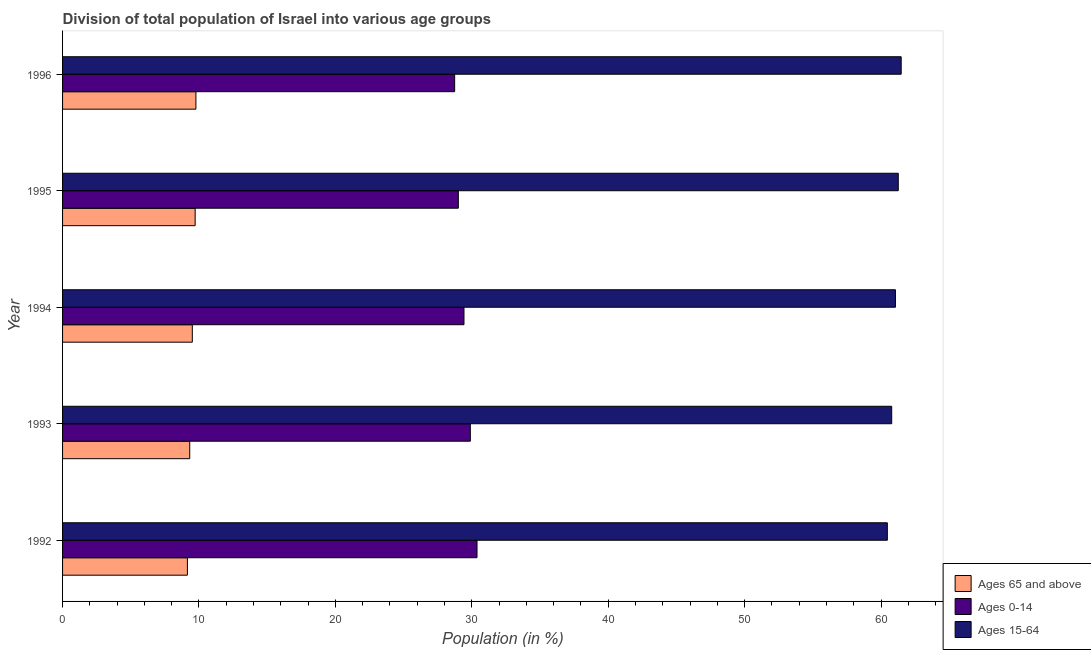How many different coloured bars are there?
Offer a very short reply. 3. Are the number of bars per tick equal to the number of legend labels?
Offer a very short reply. Yes. What is the label of the 5th group of bars from the top?
Offer a very short reply. 1992. What is the percentage of population within the age-group 15-64 in 1994?
Make the answer very short. 61.06. Across all years, what is the maximum percentage of population within the age-group 15-64?
Give a very brief answer. 61.48. Across all years, what is the minimum percentage of population within the age-group 15-64?
Your answer should be compact. 60.47. In which year was the percentage of population within the age-group 15-64 maximum?
Your response must be concise. 1996. What is the total percentage of population within the age-group 15-64 in the graph?
Provide a succinct answer. 305.05. What is the difference between the percentage of population within the age-group 0-14 in 1994 and that in 1995?
Your answer should be very brief. 0.41. What is the difference between the percentage of population within the age-group 0-14 in 1996 and the percentage of population within the age-group of 65 and above in 1993?
Your answer should be compact. 19.42. What is the average percentage of population within the age-group 15-64 per year?
Provide a succinct answer. 61.01. In the year 1994, what is the difference between the percentage of population within the age-group 15-64 and percentage of population within the age-group of 65 and above?
Offer a very short reply. 51.55. In how many years, is the percentage of population within the age-group 0-14 greater than 36 %?
Offer a terse response. 0. What is the difference between the highest and the second highest percentage of population within the age-group 15-64?
Make the answer very short. 0.21. What is the difference between the highest and the lowest percentage of population within the age-group 0-14?
Keep it short and to the point. 1.64. Is the sum of the percentage of population within the age-group of 65 and above in 1993 and 1996 greater than the maximum percentage of population within the age-group 15-64 across all years?
Offer a very short reply. No. What does the 1st bar from the top in 1993 represents?
Your answer should be very brief. Ages 15-64. What does the 3rd bar from the bottom in 1992 represents?
Keep it short and to the point. Ages 15-64. Is it the case that in every year, the sum of the percentage of population within the age-group of 65 and above and percentage of population within the age-group 0-14 is greater than the percentage of population within the age-group 15-64?
Your response must be concise. No. Are all the bars in the graph horizontal?
Ensure brevity in your answer.  Yes. What is the difference between two consecutive major ticks on the X-axis?
Make the answer very short. 10. Where does the legend appear in the graph?
Your answer should be very brief. Bottom right. How many legend labels are there?
Offer a terse response. 3. How are the legend labels stacked?
Keep it short and to the point. Vertical. What is the title of the graph?
Provide a short and direct response. Division of total population of Israel into various age groups
. Does "Neonatal" appear as one of the legend labels in the graph?
Your response must be concise. No. What is the label or title of the X-axis?
Provide a succinct answer. Population (in %). What is the label or title of the Y-axis?
Provide a short and direct response. Year. What is the Population (in %) of Ages 65 and above in 1992?
Keep it short and to the point. 9.15. What is the Population (in %) in Ages 0-14 in 1992?
Your response must be concise. 30.38. What is the Population (in %) of Ages 15-64 in 1992?
Your answer should be very brief. 60.47. What is the Population (in %) in Ages 65 and above in 1993?
Your answer should be very brief. 9.32. What is the Population (in %) of Ages 0-14 in 1993?
Offer a terse response. 29.89. What is the Population (in %) of Ages 15-64 in 1993?
Your answer should be very brief. 60.78. What is the Population (in %) in Ages 65 and above in 1994?
Your answer should be very brief. 9.51. What is the Population (in %) in Ages 0-14 in 1994?
Your answer should be very brief. 29.43. What is the Population (in %) in Ages 15-64 in 1994?
Your answer should be very brief. 61.06. What is the Population (in %) in Ages 65 and above in 1995?
Offer a terse response. 9.72. What is the Population (in %) in Ages 0-14 in 1995?
Make the answer very short. 29.01. What is the Population (in %) of Ages 15-64 in 1995?
Offer a terse response. 61.27. What is the Population (in %) in Ages 65 and above in 1996?
Offer a very short reply. 9.78. What is the Population (in %) in Ages 0-14 in 1996?
Give a very brief answer. 28.74. What is the Population (in %) of Ages 15-64 in 1996?
Your response must be concise. 61.48. Across all years, what is the maximum Population (in %) in Ages 65 and above?
Ensure brevity in your answer.  9.78. Across all years, what is the maximum Population (in %) in Ages 0-14?
Give a very brief answer. 30.38. Across all years, what is the maximum Population (in %) of Ages 15-64?
Your response must be concise. 61.48. Across all years, what is the minimum Population (in %) in Ages 65 and above?
Offer a terse response. 9.15. Across all years, what is the minimum Population (in %) in Ages 0-14?
Your response must be concise. 28.74. Across all years, what is the minimum Population (in %) of Ages 15-64?
Ensure brevity in your answer.  60.47. What is the total Population (in %) of Ages 65 and above in the graph?
Offer a very short reply. 47.48. What is the total Population (in %) in Ages 0-14 in the graph?
Your answer should be compact. 147.46. What is the total Population (in %) of Ages 15-64 in the graph?
Your answer should be compact. 305.05. What is the difference between the Population (in %) of Ages 65 and above in 1992 and that in 1993?
Your response must be concise. -0.17. What is the difference between the Population (in %) in Ages 0-14 in 1992 and that in 1993?
Ensure brevity in your answer.  0.49. What is the difference between the Population (in %) of Ages 15-64 in 1992 and that in 1993?
Make the answer very short. -0.32. What is the difference between the Population (in %) of Ages 65 and above in 1992 and that in 1994?
Offer a terse response. -0.36. What is the difference between the Population (in %) in Ages 0-14 in 1992 and that in 1994?
Provide a short and direct response. 0.95. What is the difference between the Population (in %) in Ages 15-64 in 1992 and that in 1994?
Offer a terse response. -0.59. What is the difference between the Population (in %) in Ages 65 and above in 1992 and that in 1995?
Your answer should be compact. -0.57. What is the difference between the Population (in %) in Ages 0-14 in 1992 and that in 1995?
Offer a terse response. 1.37. What is the difference between the Population (in %) of Ages 15-64 in 1992 and that in 1995?
Your response must be concise. -0.8. What is the difference between the Population (in %) in Ages 65 and above in 1992 and that in 1996?
Offer a very short reply. -0.62. What is the difference between the Population (in %) of Ages 0-14 in 1992 and that in 1996?
Ensure brevity in your answer.  1.64. What is the difference between the Population (in %) of Ages 15-64 in 1992 and that in 1996?
Make the answer very short. -1.01. What is the difference between the Population (in %) of Ages 65 and above in 1993 and that in 1994?
Provide a short and direct response. -0.19. What is the difference between the Population (in %) of Ages 0-14 in 1993 and that in 1994?
Offer a terse response. 0.46. What is the difference between the Population (in %) of Ages 15-64 in 1993 and that in 1994?
Your answer should be very brief. -0.27. What is the difference between the Population (in %) in Ages 65 and above in 1993 and that in 1995?
Provide a short and direct response. -0.4. What is the difference between the Population (in %) in Ages 0-14 in 1993 and that in 1995?
Give a very brief answer. 0.88. What is the difference between the Population (in %) in Ages 15-64 in 1993 and that in 1995?
Your answer should be very brief. -0.48. What is the difference between the Population (in %) in Ages 65 and above in 1993 and that in 1996?
Provide a succinct answer. -0.45. What is the difference between the Population (in %) of Ages 0-14 in 1993 and that in 1996?
Ensure brevity in your answer.  1.15. What is the difference between the Population (in %) of Ages 15-64 in 1993 and that in 1996?
Your response must be concise. -0.7. What is the difference between the Population (in %) of Ages 65 and above in 1994 and that in 1995?
Make the answer very short. -0.21. What is the difference between the Population (in %) in Ages 0-14 in 1994 and that in 1995?
Your answer should be compact. 0.41. What is the difference between the Population (in %) in Ages 15-64 in 1994 and that in 1995?
Provide a short and direct response. -0.21. What is the difference between the Population (in %) of Ages 65 and above in 1994 and that in 1996?
Your response must be concise. -0.26. What is the difference between the Population (in %) of Ages 0-14 in 1994 and that in 1996?
Offer a very short reply. 0.68. What is the difference between the Population (in %) of Ages 15-64 in 1994 and that in 1996?
Offer a terse response. -0.42. What is the difference between the Population (in %) in Ages 65 and above in 1995 and that in 1996?
Provide a short and direct response. -0.06. What is the difference between the Population (in %) of Ages 0-14 in 1995 and that in 1996?
Your answer should be compact. 0.27. What is the difference between the Population (in %) of Ages 15-64 in 1995 and that in 1996?
Offer a terse response. -0.21. What is the difference between the Population (in %) in Ages 65 and above in 1992 and the Population (in %) in Ages 0-14 in 1993?
Your answer should be compact. -20.74. What is the difference between the Population (in %) in Ages 65 and above in 1992 and the Population (in %) in Ages 15-64 in 1993?
Ensure brevity in your answer.  -51.63. What is the difference between the Population (in %) in Ages 0-14 in 1992 and the Population (in %) in Ages 15-64 in 1993?
Your answer should be compact. -30.4. What is the difference between the Population (in %) of Ages 65 and above in 1992 and the Population (in %) of Ages 0-14 in 1994?
Provide a short and direct response. -20.28. What is the difference between the Population (in %) of Ages 65 and above in 1992 and the Population (in %) of Ages 15-64 in 1994?
Your response must be concise. -51.91. What is the difference between the Population (in %) in Ages 0-14 in 1992 and the Population (in %) in Ages 15-64 in 1994?
Give a very brief answer. -30.68. What is the difference between the Population (in %) of Ages 65 and above in 1992 and the Population (in %) of Ages 0-14 in 1995?
Your answer should be compact. -19.86. What is the difference between the Population (in %) in Ages 65 and above in 1992 and the Population (in %) in Ages 15-64 in 1995?
Offer a terse response. -52.11. What is the difference between the Population (in %) in Ages 0-14 in 1992 and the Population (in %) in Ages 15-64 in 1995?
Ensure brevity in your answer.  -30.88. What is the difference between the Population (in %) in Ages 65 and above in 1992 and the Population (in %) in Ages 0-14 in 1996?
Ensure brevity in your answer.  -19.59. What is the difference between the Population (in %) of Ages 65 and above in 1992 and the Population (in %) of Ages 15-64 in 1996?
Provide a succinct answer. -52.33. What is the difference between the Population (in %) in Ages 0-14 in 1992 and the Population (in %) in Ages 15-64 in 1996?
Your answer should be compact. -31.1. What is the difference between the Population (in %) of Ages 65 and above in 1993 and the Population (in %) of Ages 0-14 in 1994?
Give a very brief answer. -20.11. What is the difference between the Population (in %) of Ages 65 and above in 1993 and the Population (in %) of Ages 15-64 in 1994?
Provide a succinct answer. -51.74. What is the difference between the Population (in %) of Ages 0-14 in 1993 and the Population (in %) of Ages 15-64 in 1994?
Your answer should be very brief. -31.17. What is the difference between the Population (in %) in Ages 65 and above in 1993 and the Population (in %) in Ages 0-14 in 1995?
Provide a succinct answer. -19.69. What is the difference between the Population (in %) of Ages 65 and above in 1993 and the Population (in %) of Ages 15-64 in 1995?
Give a very brief answer. -51.94. What is the difference between the Population (in %) of Ages 0-14 in 1993 and the Population (in %) of Ages 15-64 in 1995?
Ensure brevity in your answer.  -31.37. What is the difference between the Population (in %) in Ages 65 and above in 1993 and the Population (in %) in Ages 0-14 in 1996?
Provide a short and direct response. -19.42. What is the difference between the Population (in %) of Ages 65 and above in 1993 and the Population (in %) of Ages 15-64 in 1996?
Offer a terse response. -52.16. What is the difference between the Population (in %) in Ages 0-14 in 1993 and the Population (in %) in Ages 15-64 in 1996?
Your answer should be compact. -31.59. What is the difference between the Population (in %) in Ages 65 and above in 1994 and the Population (in %) in Ages 0-14 in 1995?
Make the answer very short. -19.5. What is the difference between the Population (in %) of Ages 65 and above in 1994 and the Population (in %) of Ages 15-64 in 1995?
Your answer should be very brief. -51.75. What is the difference between the Population (in %) of Ages 0-14 in 1994 and the Population (in %) of Ages 15-64 in 1995?
Provide a short and direct response. -31.84. What is the difference between the Population (in %) of Ages 65 and above in 1994 and the Population (in %) of Ages 0-14 in 1996?
Offer a very short reply. -19.23. What is the difference between the Population (in %) in Ages 65 and above in 1994 and the Population (in %) in Ages 15-64 in 1996?
Offer a terse response. -51.97. What is the difference between the Population (in %) in Ages 0-14 in 1994 and the Population (in %) in Ages 15-64 in 1996?
Offer a terse response. -32.05. What is the difference between the Population (in %) in Ages 65 and above in 1995 and the Population (in %) in Ages 0-14 in 1996?
Make the answer very short. -19.02. What is the difference between the Population (in %) in Ages 65 and above in 1995 and the Population (in %) in Ages 15-64 in 1996?
Offer a very short reply. -51.76. What is the difference between the Population (in %) of Ages 0-14 in 1995 and the Population (in %) of Ages 15-64 in 1996?
Your answer should be very brief. -32.47. What is the average Population (in %) of Ages 65 and above per year?
Your response must be concise. 9.5. What is the average Population (in %) of Ages 0-14 per year?
Offer a terse response. 29.49. What is the average Population (in %) of Ages 15-64 per year?
Your answer should be compact. 61.01. In the year 1992, what is the difference between the Population (in %) of Ages 65 and above and Population (in %) of Ages 0-14?
Provide a succinct answer. -21.23. In the year 1992, what is the difference between the Population (in %) in Ages 65 and above and Population (in %) in Ages 15-64?
Make the answer very short. -51.31. In the year 1992, what is the difference between the Population (in %) in Ages 0-14 and Population (in %) in Ages 15-64?
Your answer should be compact. -30.08. In the year 1993, what is the difference between the Population (in %) in Ages 65 and above and Population (in %) in Ages 0-14?
Your answer should be very brief. -20.57. In the year 1993, what is the difference between the Population (in %) in Ages 65 and above and Population (in %) in Ages 15-64?
Keep it short and to the point. -51.46. In the year 1993, what is the difference between the Population (in %) of Ages 0-14 and Population (in %) of Ages 15-64?
Provide a short and direct response. -30.89. In the year 1994, what is the difference between the Population (in %) of Ages 65 and above and Population (in %) of Ages 0-14?
Make the answer very short. -19.92. In the year 1994, what is the difference between the Population (in %) of Ages 65 and above and Population (in %) of Ages 15-64?
Your answer should be very brief. -51.55. In the year 1994, what is the difference between the Population (in %) of Ages 0-14 and Population (in %) of Ages 15-64?
Give a very brief answer. -31.63. In the year 1995, what is the difference between the Population (in %) in Ages 65 and above and Population (in %) in Ages 0-14?
Provide a succinct answer. -19.29. In the year 1995, what is the difference between the Population (in %) in Ages 65 and above and Population (in %) in Ages 15-64?
Keep it short and to the point. -51.55. In the year 1995, what is the difference between the Population (in %) of Ages 0-14 and Population (in %) of Ages 15-64?
Offer a very short reply. -32.25. In the year 1996, what is the difference between the Population (in %) of Ages 65 and above and Population (in %) of Ages 0-14?
Provide a short and direct response. -18.97. In the year 1996, what is the difference between the Population (in %) of Ages 65 and above and Population (in %) of Ages 15-64?
Keep it short and to the point. -51.7. In the year 1996, what is the difference between the Population (in %) of Ages 0-14 and Population (in %) of Ages 15-64?
Provide a short and direct response. -32.74. What is the ratio of the Population (in %) of Ages 65 and above in 1992 to that in 1993?
Offer a terse response. 0.98. What is the ratio of the Population (in %) in Ages 0-14 in 1992 to that in 1993?
Your answer should be compact. 1.02. What is the ratio of the Population (in %) in Ages 15-64 in 1992 to that in 1993?
Offer a very short reply. 0.99. What is the ratio of the Population (in %) of Ages 65 and above in 1992 to that in 1994?
Offer a very short reply. 0.96. What is the ratio of the Population (in %) in Ages 0-14 in 1992 to that in 1994?
Provide a short and direct response. 1.03. What is the ratio of the Population (in %) of Ages 15-64 in 1992 to that in 1994?
Your answer should be very brief. 0.99. What is the ratio of the Population (in %) of Ages 65 and above in 1992 to that in 1995?
Keep it short and to the point. 0.94. What is the ratio of the Population (in %) in Ages 0-14 in 1992 to that in 1995?
Offer a very short reply. 1.05. What is the ratio of the Population (in %) in Ages 15-64 in 1992 to that in 1995?
Make the answer very short. 0.99. What is the ratio of the Population (in %) of Ages 65 and above in 1992 to that in 1996?
Provide a short and direct response. 0.94. What is the ratio of the Population (in %) of Ages 0-14 in 1992 to that in 1996?
Give a very brief answer. 1.06. What is the ratio of the Population (in %) in Ages 15-64 in 1992 to that in 1996?
Your answer should be compact. 0.98. What is the ratio of the Population (in %) of Ages 65 and above in 1993 to that in 1994?
Make the answer very short. 0.98. What is the ratio of the Population (in %) of Ages 0-14 in 1993 to that in 1994?
Keep it short and to the point. 1.02. What is the ratio of the Population (in %) in Ages 65 and above in 1993 to that in 1995?
Keep it short and to the point. 0.96. What is the ratio of the Population (in %) of Ages 0-14 in 1993 to that in 1995?
Provide a succinct answer. 1.03. What is the ratio of the Population (in %) in Ages 65 and above in 1993 to that in 1996?
Ensure brevity in your answer.  0.95. What is the ratio of the Population (in %) of Ages 0-14 in 1993 to that in 1996?
Give a very brief answer. 1.04. What is the ratio of the Population (in %) in Ages 15-64 in 1993 to that in 1996?
Make the answer very short. 0.99. What is the ratio of the Population (in %) of Ages 65 and above in 1994 to that in 1995?
Your answer should be compact. 0.98. What is the ratio of the Population (in %) in Ages 0-14 in 1994 to that in 1995?
Provide a succinct answer. 1.01. What is the ratio of the Population (in %) of Ages 15-64 in 1994 to that in 1995?
Your answer should be compact. 1. What is the ratio of the Population (in %) of Ages 0-14 in 1994 to that in 1996?
Your answer should be compact. 1.02. What is the ratio of the Population (in %) of Ages 15-64 in 1994 to that in 1996?
Your response must be concise. 0.99. What is the ratio of the Population (in %) in Ages 65 and above in 1995 to that in 1996?
Keep it short and to the point. 0.99. What is the ratio of the Population (in %) of Ages 0-14 in 1995 to that in 1996?
Provide a short and direct response. 1.01. What is the difference between the highest and the second highest Population (in %) of Ages 65 and above?
Provide a short and direct response. 0.06. What is the difference between the highest and the second highest Population (in %) in Ages 0-14?
Keep it short and to the point. 0.49. What is the difference between the highest and the second highest Population (in %) of Ages 15-64?
Make the answer very short. 0.21. What is the difference between the highest and the lowest Population (in %) of Ages 65 and above?
Offer a very short reply. 0.62. What is the difference between the highest and the lowest Population (in %) in Ages 0-14?
Provide a succinct answer. 1.64. What is the difference between the highest and the lowest Population (in %) of Ages 15-64?
Your answer should be very brief. 1.01. 